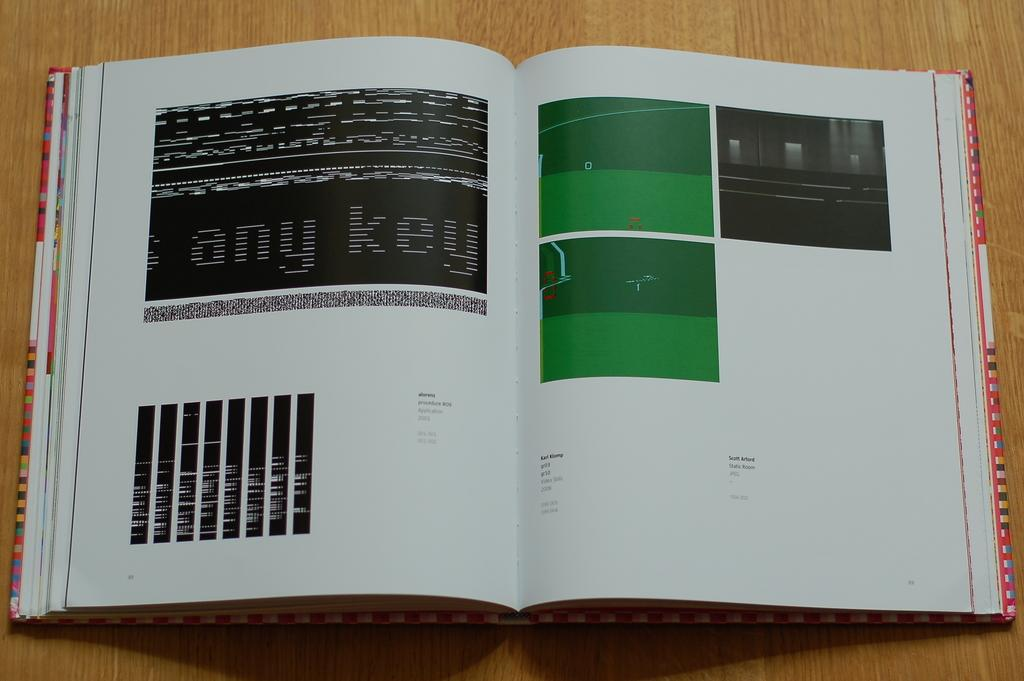<image>
Share a concise interpretation of the image provided. the word any is on the left page of the book 